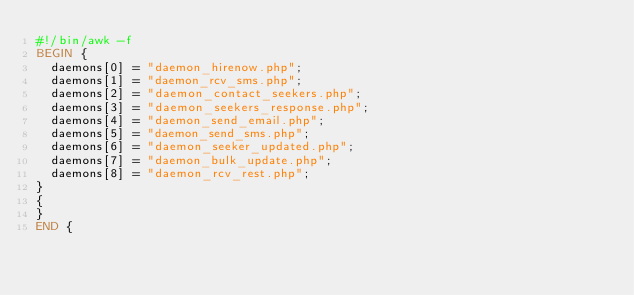Convert code to text. <code><loc_0><loc_0><loc_500><loc_500><_Awk_>#!/bin/awk -f
BEGIN {
  daemons[0] = "daemon_hirenow.php";
  daemons[1] = "daemon_rcv_sms.php";
  daemons[2] = "daemon_contact_seekers.php";
  daemons[3] = "daemon_seekers_response.php";
  daemons[4] = "daemon_send_email.php";
  daemons[5] = "daemon_send_sms.php";
  daemons[6] = "daemon_seeker_updated.php";
  daemons[7] = "daemon_bulk_update.php";
  daemons[8] = "daemon_rcv_rest.php";
}
{
}
END {</code> 